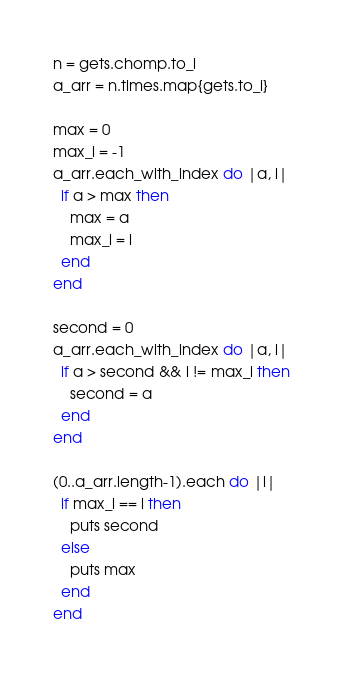<code> <loc_0><loc_0><loc_500><loc_500><_Ruby_>n = gets.chomp.to_i
a_arr = n.times.map{gets.to_i}

max = 0
max_i = -1
a_arr.each_with_index do |a, i|
  if a > max then
    max = a
    max_i = i
  end
end

second = 0
a_arr.each_with_index do |a, i|
  if a > second && i != max_i then
    second = a
  end
end

(0..a_arr.length-1).each do |i|
  if max_i == i then
    puts second
  else
    puts max
  end
end
</code> 